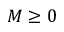Convert formula to latex. <formula><loc_0><loc_0><loc_500><loc_500>M \geq 0</formula> 